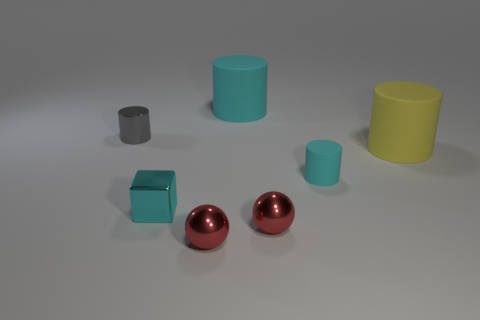How many other things are there of the same material as the yellow cylinder?
Offer a terse response. 2. Are there fewer brown shiny spheres than small shiny cylinders?
Ensure brevity in your answer.  Yes. Is the shape of the big matte thing behind the yellow rubber cylinder the same as the object that is left of the cyan metallic thing?
Your answer should be compact. Yes. The small block is what color?
Your answer should be very brief. Cyan. What number of rubber objects are either large cyan cylinders or tiny gray cylinders?
Make the answer very short. 1. The tiny rubber object that is the same shape as the large yellow matte thing is what color?
Make the answer very short. Cyan. Is there a cyan cylinder?
Offer a terse response. Yes. Does the small thing that is behind the yellow matte thing have the same material as the cyan cylinder behind the small cyan matte cylinder?
Keep it short and to the point. No. The small matte object that is the same color as the small cube is what shape?
Give a very brief answer. Cylinder. What number of things are cyan matte cylinders in front of the yellow object or tiny cylinders on the left side of the cube?
Keep it short and to the point. 2. 